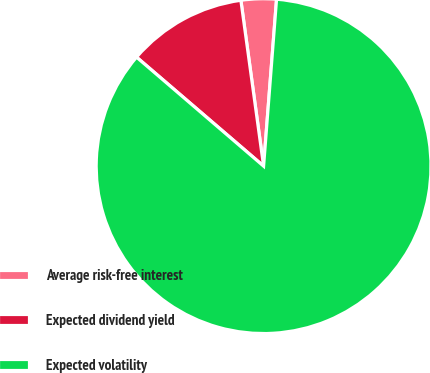<chart> <loc_0><loc_0><loc_500><loc_500><pie_chart><fcel>Average risk-free interest<fcel>Expected dividend yield<fcel>Expected volatility<nl><fcel>3.4%<fcel>11.55%<fcel>85.05%<nl></chart> 